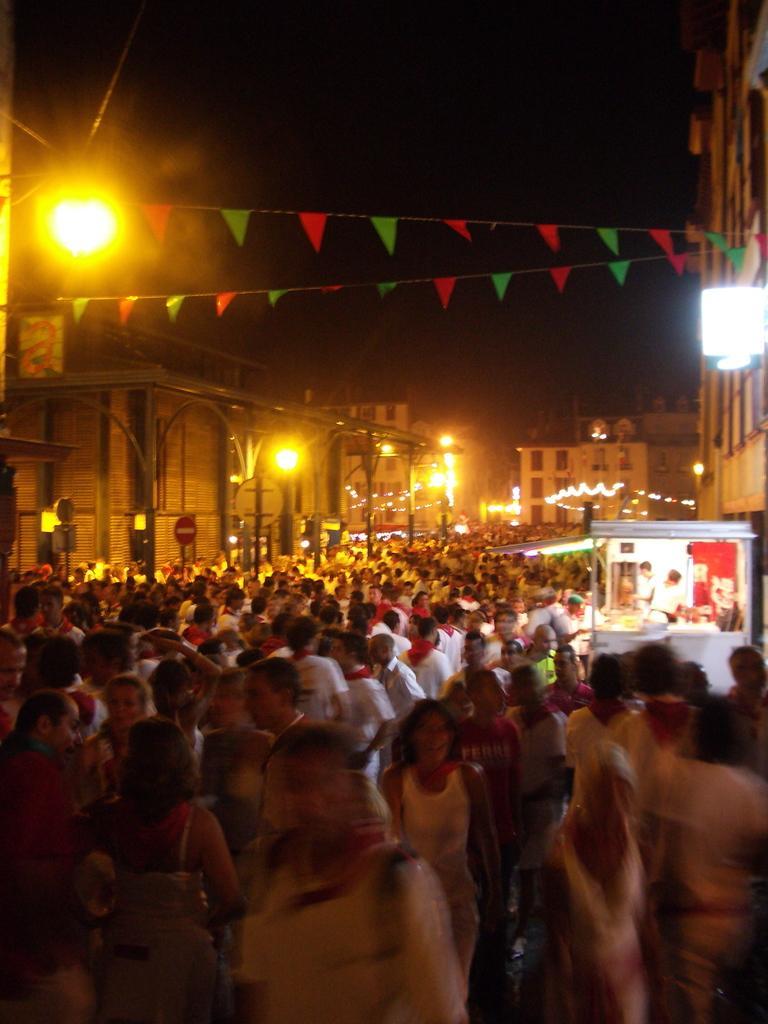How would you summarize this image in a sentence or two? In the image there is a huge crowd and on the right side there is some food stall, around the crowd there are many buildings and street lights. 